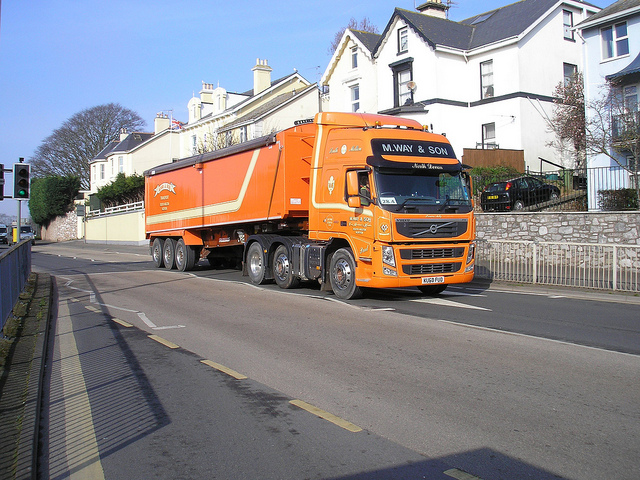Identify the text displayed in this image. M WAY SON 